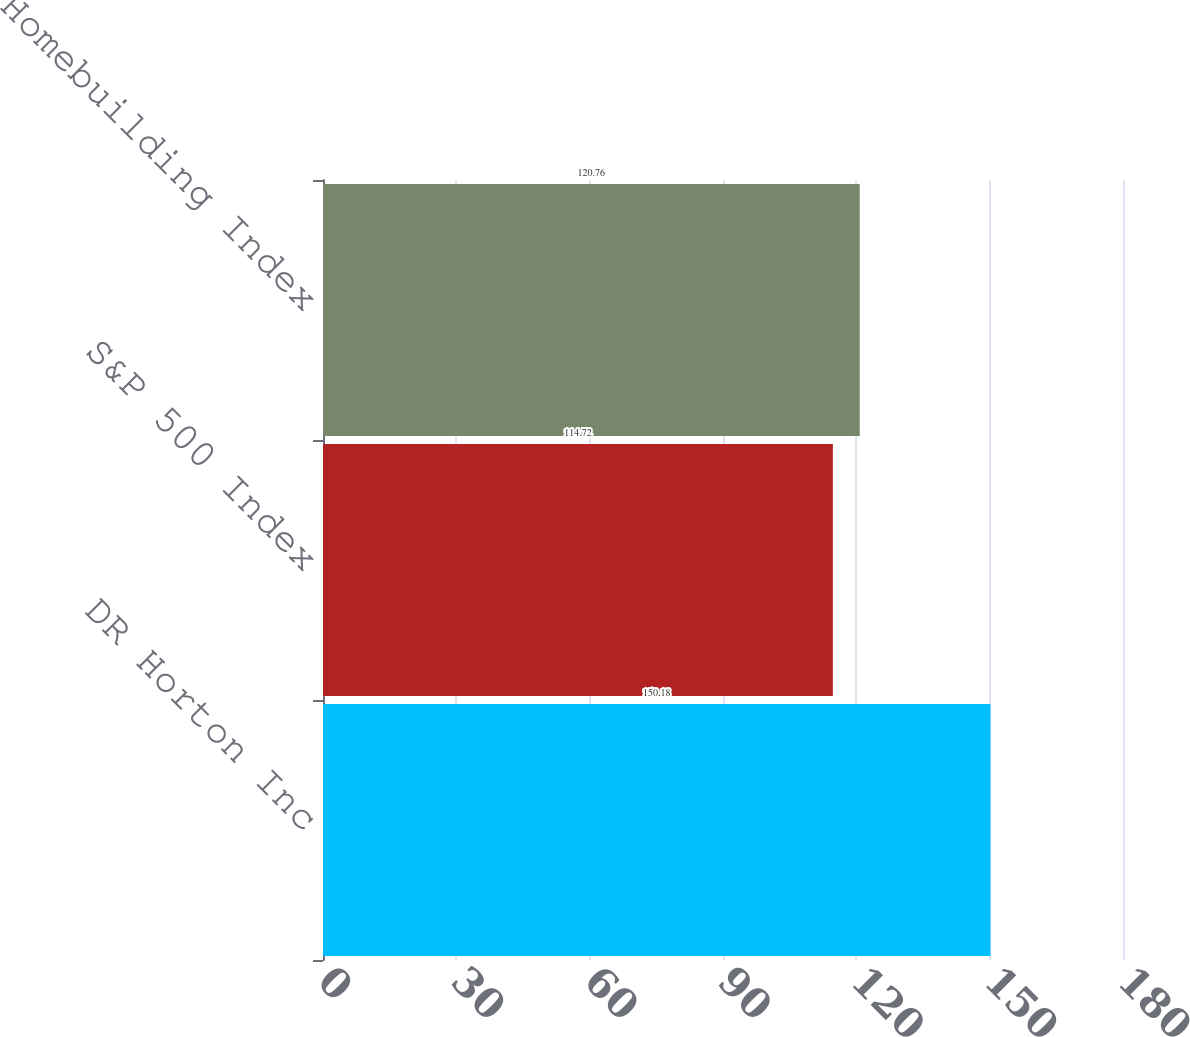<chart> <loc_0><loc_0><loc_500><loc_500><bar_chart><fcel>DR Horton Inc<fcel>S&P 500 Index<fcel>S&P 1500 Homebuilding Index<nl><fcel>150.18<fcel>114.72<fcel>120.76<nl></chart> 